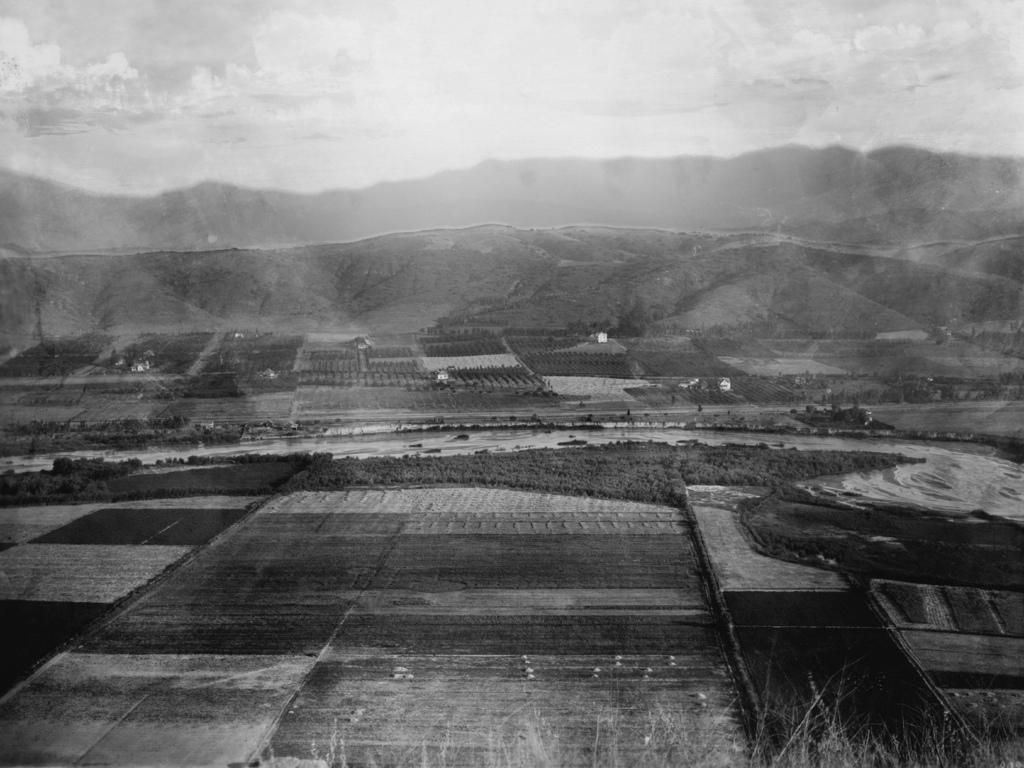What type of landscape is depicted in the image? The image features fields that are planted. What other natural elements can be seen in the image? There are trees, mountains, and the sky visible in the image. How many bananas can be seen hanging from the trees in the image? There are no bananas visible in the image; the trees in the image do not have bananas. What type of pin is used to hold the mountains together in the image? There is no pin present in the image; the mountains are naturally connected. 